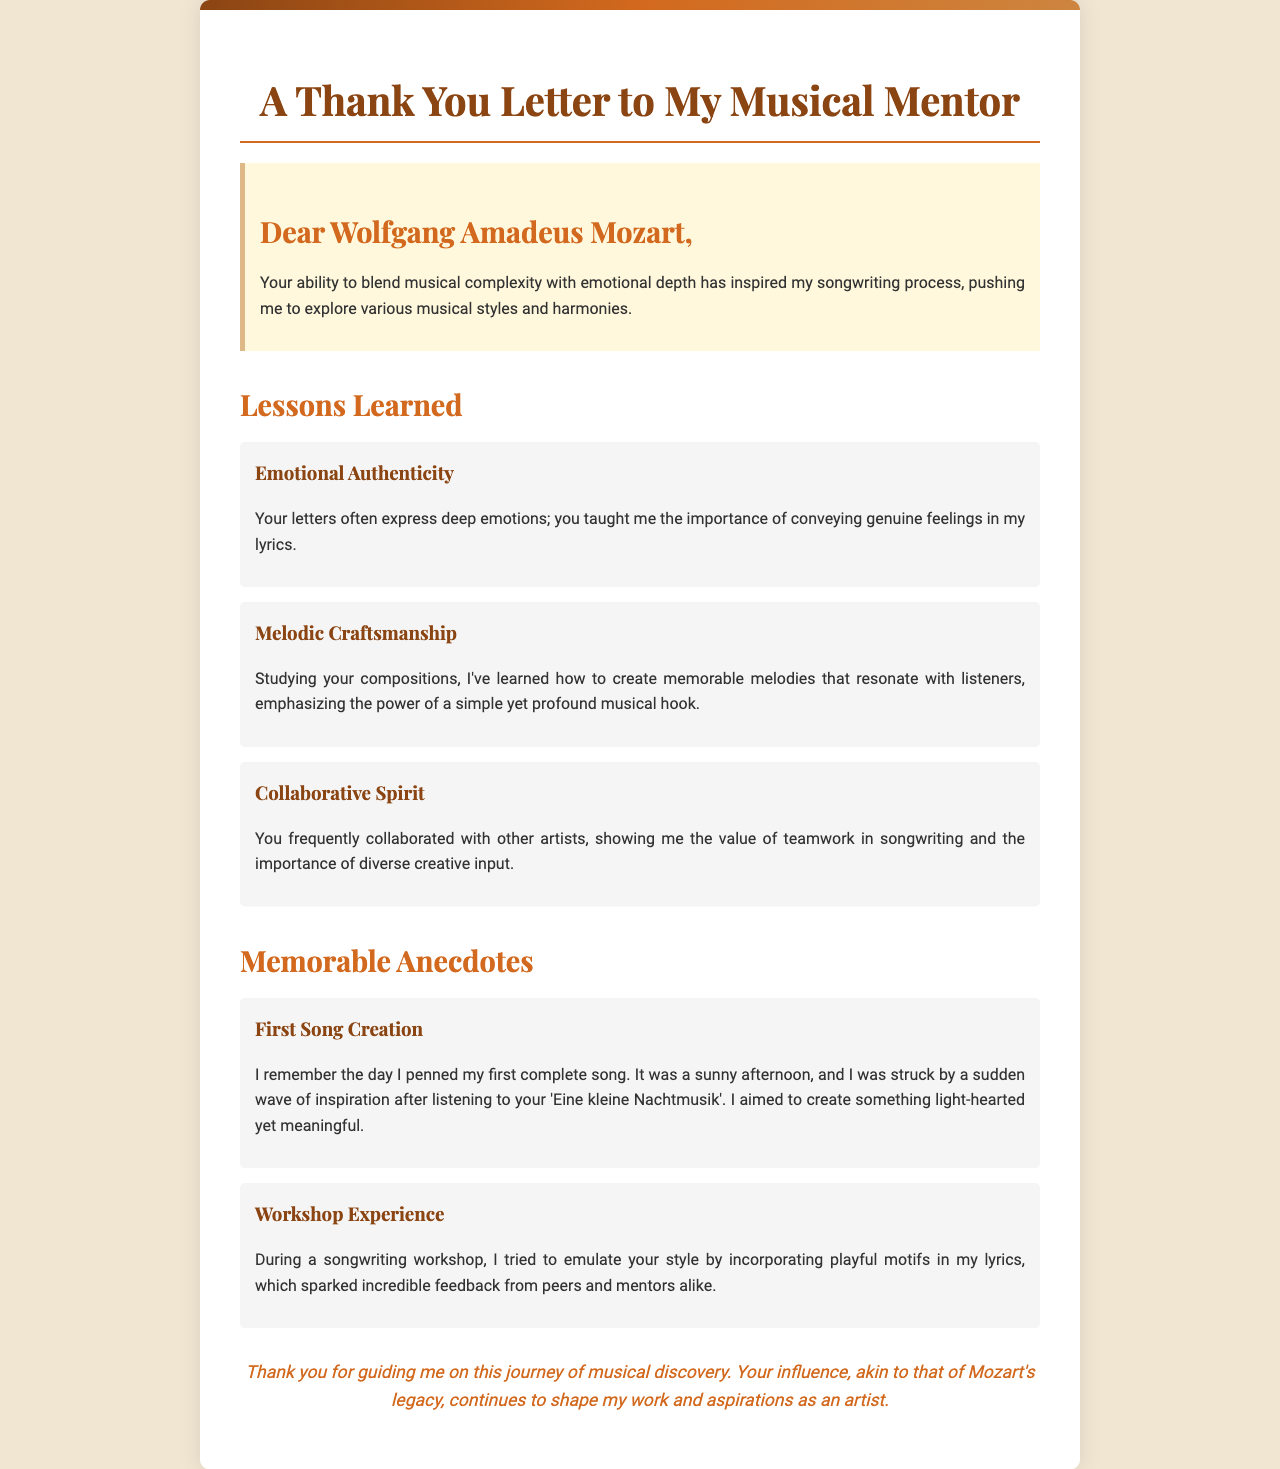What is the title of the letter? The title of the letter is at the top of the document header, prominently displayed.
Answer: A Thank You Letter to My Musical Mentor Who is the letter addressed to? The recipient's name is mentioned at the beginning of the letter in the salutation.
Answer: Wolfgang Amadeus Mozart What are the three lessons learned from the mentor? The lessons are clearly listed in the document under the "Lessons Learned" section.
Answer: Emotional Authenticity, Melodic Craftsmanship, Collaborative Spirit What is the first memorable anecdote mentioned? The first anecdote is titled and described in the "Memorable Anecdotes" section of the document.
Answer: First Song Creation What did the songwriter try to emulate in the workshop experience? This information is found within the description of the second anecdote under "Memorable Anecdotes."
Answer: Your style What is a key theme discussed in the lessons learned section? This theme can be inferred from the titles and contents of the lessons.
Answer: Emotional authenticity What color is used for the background of the letter? The background color is noted in the style section of the document.
Answer: #f0e6d2 How does the letter conclude? The conclusion is provided in the final paragraph of the document; it summarizes the writer's feelings.
Answer: Thank you for guiding me on this journey of musical discovery 